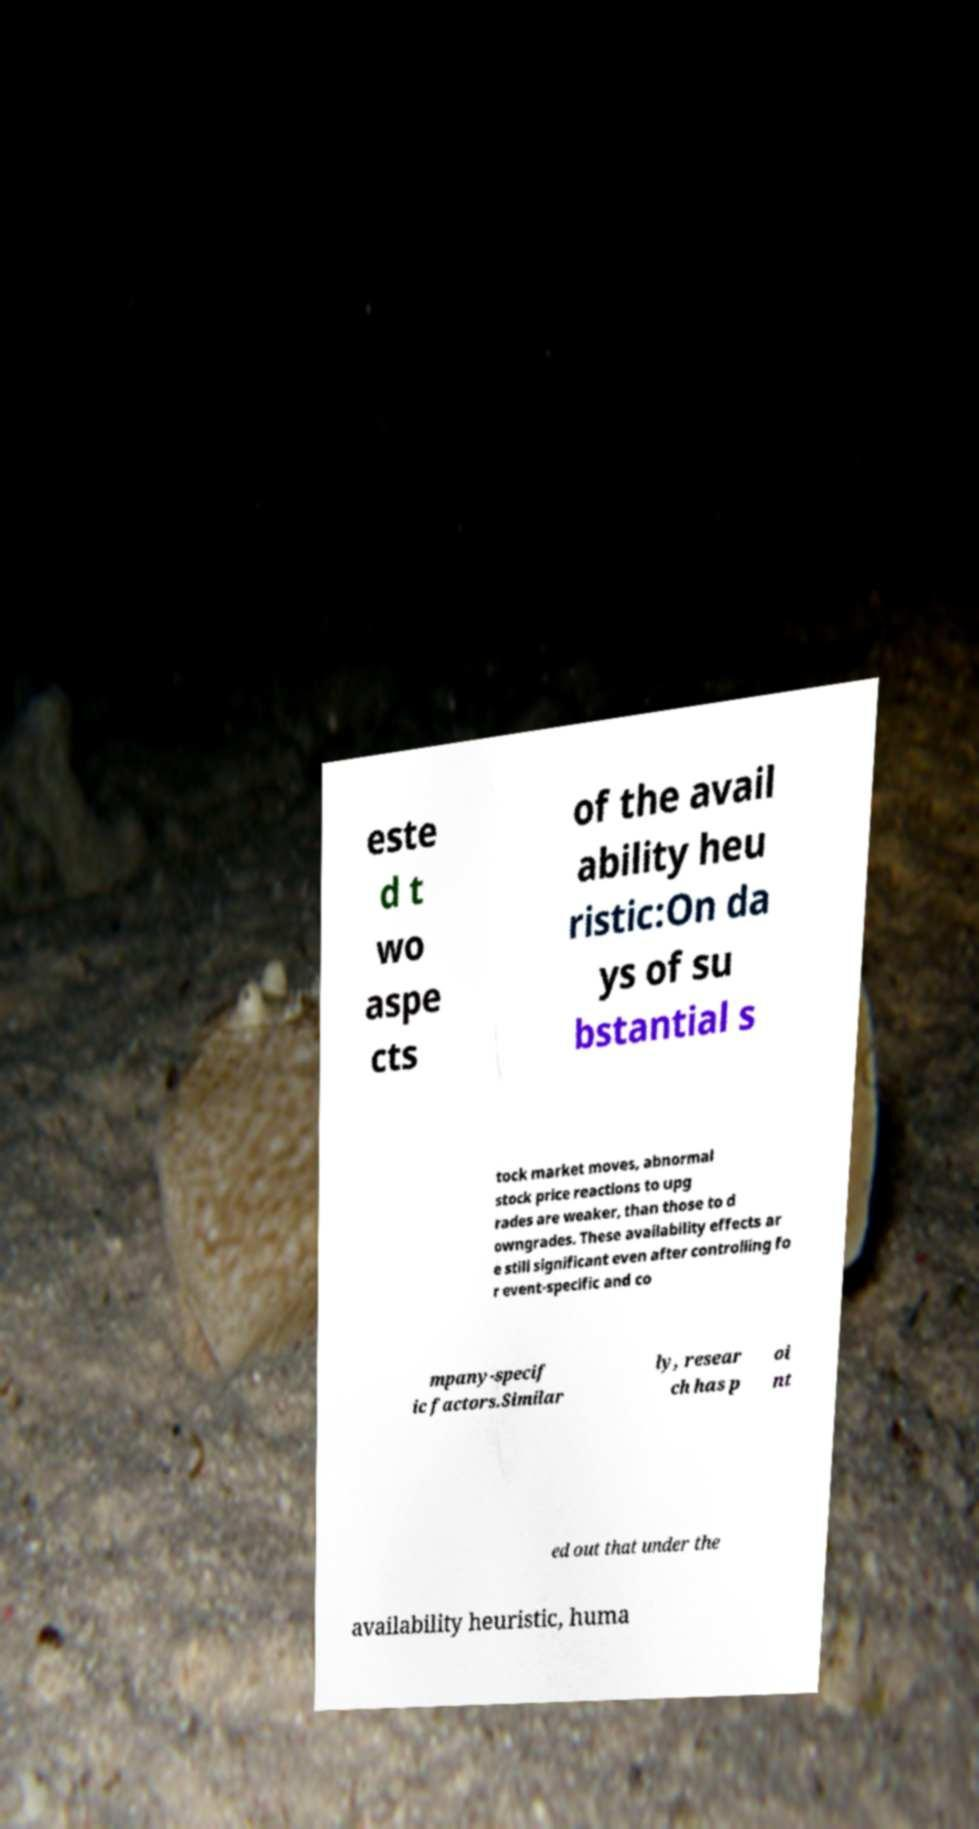I need the written content from this picture converted into text. Can you do that? este d t wo aspe cts of the avail ability heu ristic:On da ys of su bstantial s tock market moves, abnormal stock price reactions to upg rades are weaker, than those to d owngrades. These availability effects ar e still significant even after controlling fo r event-specific and co mpany-specif ic factors.Similar ly, resear ch has p oi nt ed out that under the availability heuristic, huma 